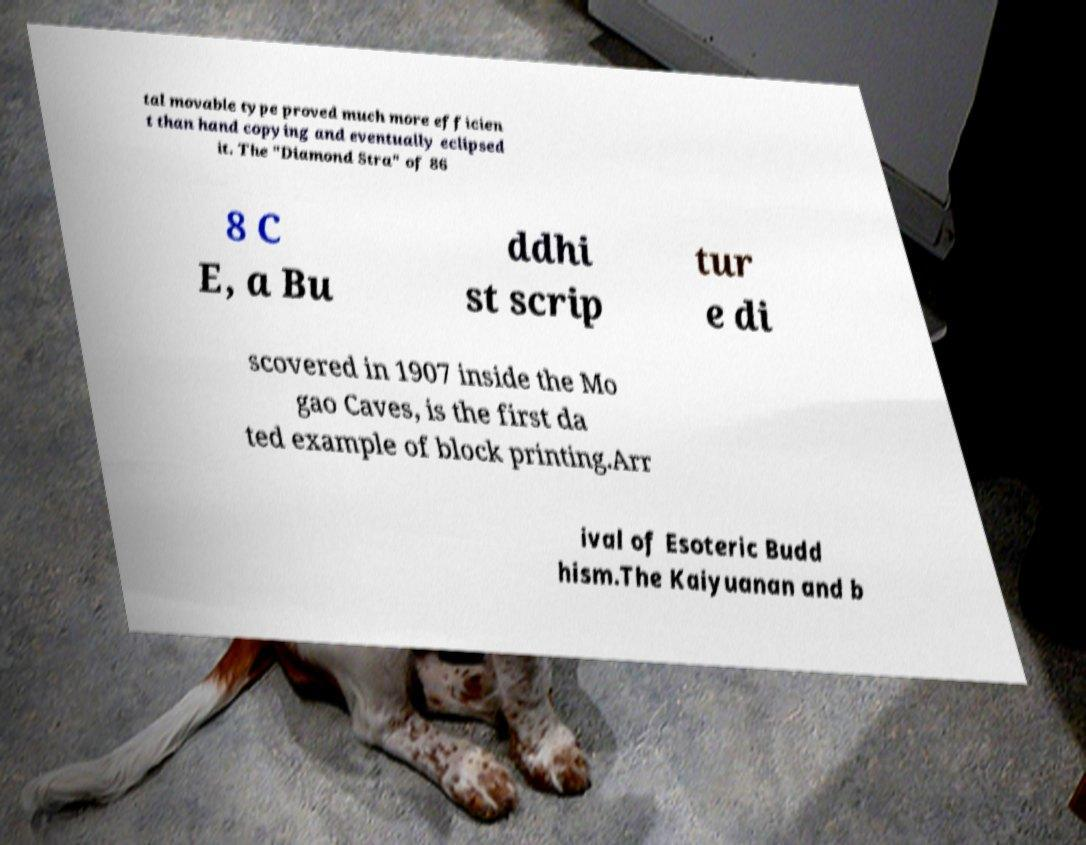I need the written content from this picture converted into text. Can you do that? tal movable type proved much more efficien t than hand copying and eventually eclipsed it. The "Diamond Stra" of 86 8 C E, a Bu ddhi st scrip tur e di scovered in 1907 inside the Mo gao Caves, is the first da ted example of block printing.Arr ival of Esoteric Budd hism.The Kaiyuanan and b 